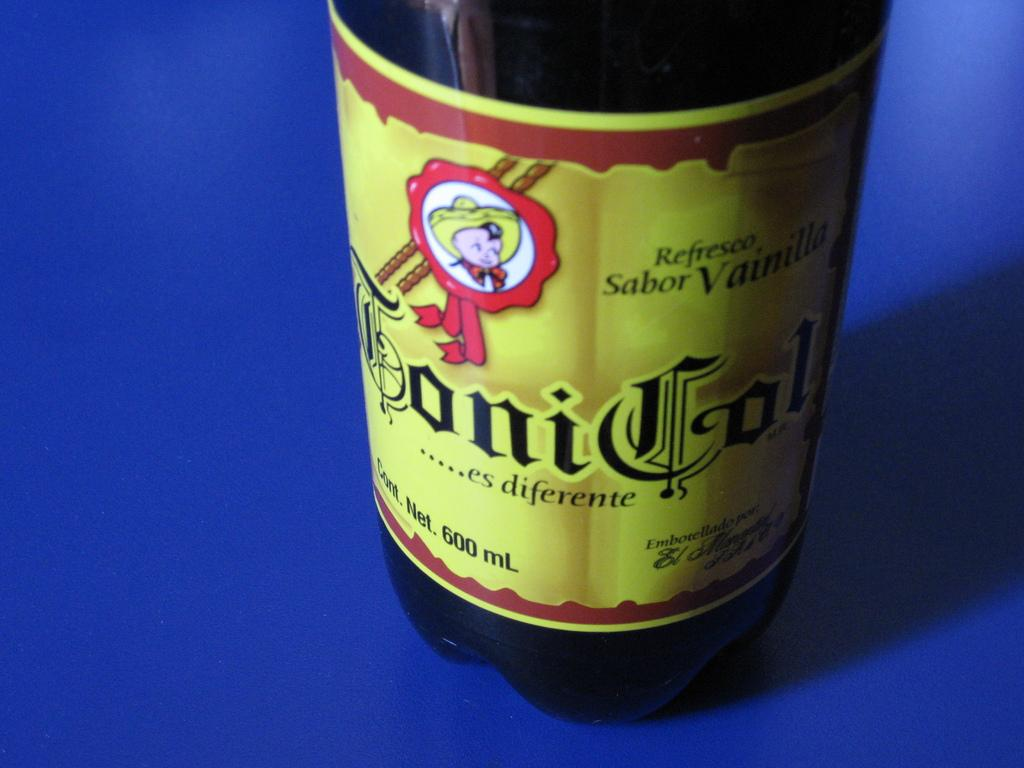<image>
Present a compact description of the photo's key features. A bottle with a child wearing a sombrero on it indicates it is vanilla flavored. 